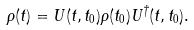Convert formula to latex. <formula><loc_0><loc_0><loc_500><loc_500>\rho ( t ) = U ( t , t _ { 0 } ) \rho ( t _ { 0 } ) U ^ { \dagger } ( t , t _ { 0 } ) .</formula> 